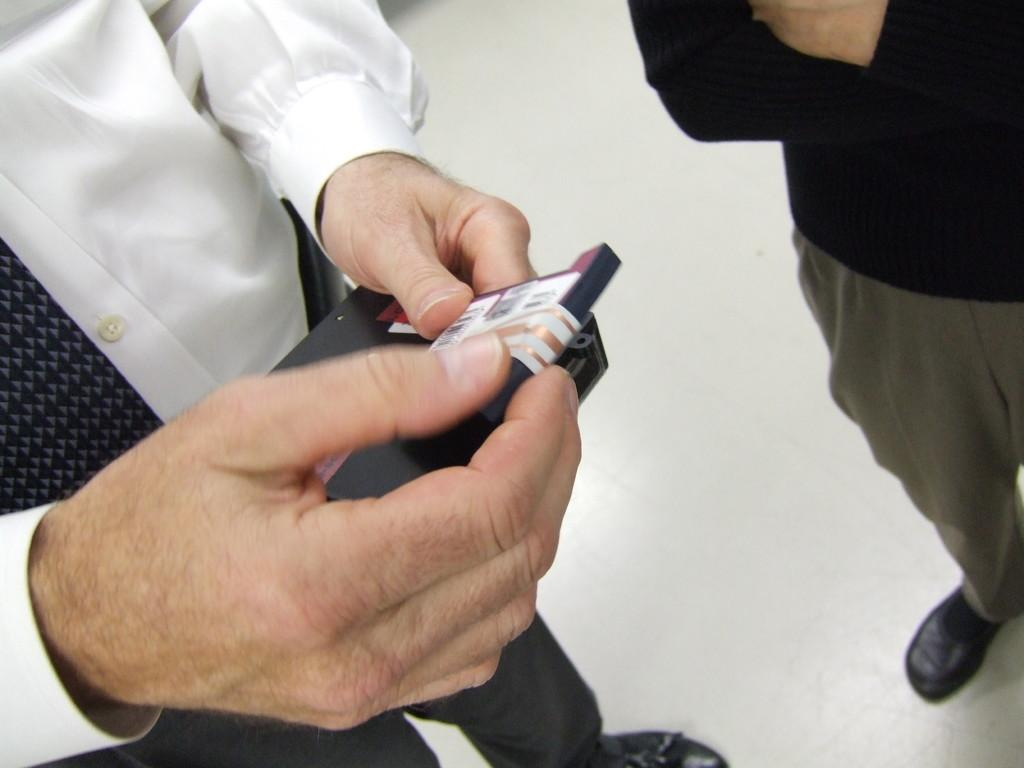How many people are in the image? There are two persons in the image. What can be seen at the bottom of the image? There is a floor visible at the bottom of the image. What type of crown is the guide wearing in the image? There is no crown or guide present in the image; it only features two persons. 